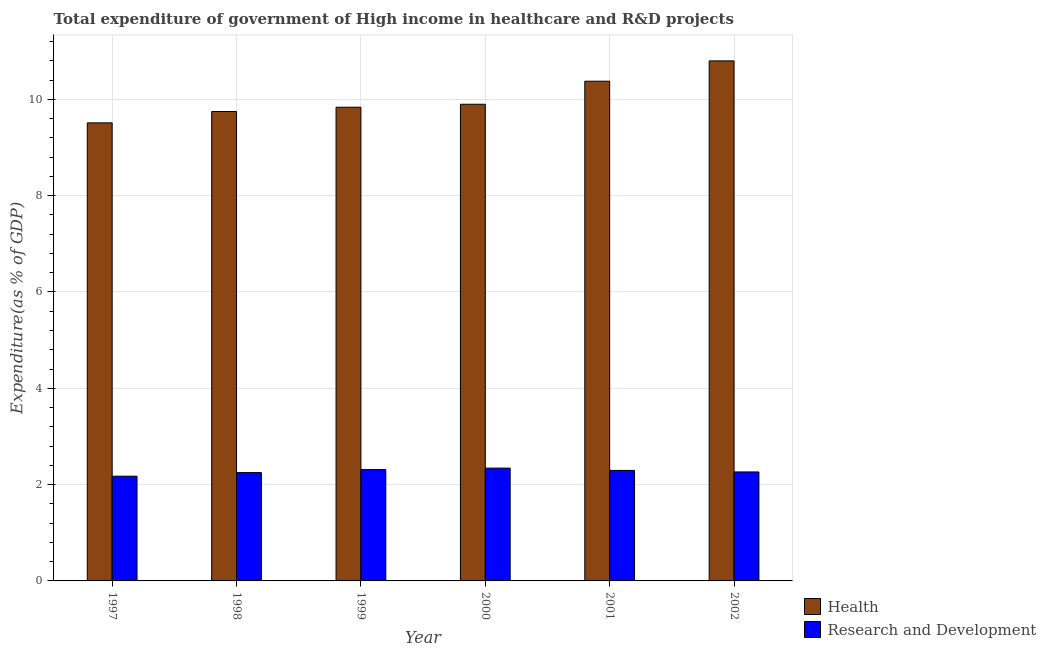How many groups of bars are there?
Keep it short and to the point. 6. Are the number of bars per tick equal to the number of legend labels?
Ensure brevity in your answer.  Yes. Are the number of bars on each tick of the X-axis equal?
Provide a short and direct response. Yes. How many bars are there on the 6th tick from the right?
Offer a very short reply. 2. What is the label of the 4th group of bars from the left?
Provide a succinct answer. 2000. What is the expenditure in r&d in 2001?
Provide a succinct answer. 2.29. Across all years, what is the maximum expenditure in healthcare?
Keep it short and to the point. 10.8. Across all years, what is the minimum expenditure in r&d?
Make the answer very short. 2.17. What is the total expenditure in healthcare in the graph?
Offer a terse response. 60.17. What is the difference between the expenditure in healthcare in 2001 and that in 2002?
Your response must be concise. -0.42. What is the difference between the expenditure in r&d in 1997 and the expenditure in healthcare in 1999?
Give a very brief answer. -0.14. What is the average expenditure in r&d per year?
Provide a short and direct response. 2.27. In the year 2001, what is the difference between the expenditure in r&d and expenditure in healthcare?
Give a very brief answer. 0. What is the ratio of the expenditure in r&d in 1998 to that in 2000?
Make the answer very short. 0.96. What is the difference between the highest and the second highest expenditure in healthcare?
Your answer should be compact. 0.42. What is the difference between the highest and the lowest expenditure in r&d?
Make the answer very short. 0.17. In how many years, is the expenditure in r&d greater than the average expenditure in r&d taken over all years?
Keep it short and to the point. 3. Is the sum of the expenditure in r&d in 1998 and 1999 greater than the maximum expenditure in healthcare across all years?
Your answer should be compact. Yes. What does the 1st bar from the left in 1999 represents?
Give a very brief answer. Health. What does the 2nd bar from the right in 2001 represents?
Offer a terse response. Health. How many bars are there?
Offer a terse response. 12. What is the difference between two consecutive major ticks on the Y-axis?
Keep it short and to the point. 2. Does the graph contain any zero values?
Your answer should be compact. No. Does the graph contain grids?
Provide a short and direct response. Yes. Where does the legend appear in the graph?
Your answer should be very brief. Bottom right. How many legend labels are there?
Your answer should be very brief. 2. How are the legend labels stacked?
Your answer should be compact. Vertical. What is the title of the graph?
Your response must be concise. Total expenditure of government of High income in healthcare and R&D projects. Does "Agricultural land" appear as one of the legend labels in the graph?
Your answer should be compact. No. What is the label or title of the Y-axis?
Make the answer very short. Expenditure(as % of GDP). What is the Expenditure(as % of GDP) in Health in 1997?
Offer a very short reply. 9.51. What is the Expenditure(as % of GDP) in Research and Development in 1997?
Make the answer very short. 2.17. What is the Expenditure(as % of GDP) in Health in 1998?
Provide a succinct answer. 9.75. What is the Expenditure(as % of GDP) in Research and Development in 1998?
Your answer should be very brief. 2.25. What is the Expenditure(as % of GDP) in Health in 1999?
Your response must be concise. 9.84. What is the Expenditure(as % of GDP) of Research and Development in 1999?
Give a very brief answer. 2.31. What is the Expenditure(as % of GDP) of Health in 2000?
Your answer should be compact. 9.9. What is the Expenditure(as % of GDP) in Research and Development in 2000?
Your response must be concise. 2.34. What is the Expenditure(as % of GDP) in Health in 2001?
Provide a succinct answer. 10.38. What is the Expenditure(as % of GDP) of Research and Development in 2001?
Give a very brief answer. 2.29. What is the Expenditure(as % of GDP) in Health in 2002?
Your answer should be very brief. 10.8. What is the Expenditure(as % of GDP) in Research and Development in 2002?
Provide a succinct answer. 2.26. Across all years, what is the maximum Expenditure(as % of GDP) of Health?
Your answer should be compact. 10.8. Across all years, what is the maximum Expenditure(as % of GDP) in Research and Development?
Your answer should be compact. 2.34. Across all years, what is the minimum Expenditure(as % of GDP) in Health?
Your answer should be very brief. 9.51. Across all years, what is the minimum Expenditure(as % of GDP) in Research and Development?
Ensure brevity in your answer.  2.17. What is the total Expenditure(as % of GDP) of Health in the graph?
Ensure brevity in your answer.  60.17. What is the total Expenditure(as % of GDP) of Research and Development in the graph?
Your answer should be very brief. 13.64. What is the difference between the Expenditure(as % of GDP) in Health in 1997 and that in 1998?
Make the answer very short. -0.24. What is the difference between the Expenditure(as % of GDP) of Research and Development in 1997 and that in 1998?
Make the answer very short. -0.08. What is the difference between the Expenditure(as % of GDP) of Health in 1997 and that in 1999?
Your answer should be very brief. -0.32. What is the difference between the Expenditure(as % of GDP) of Research and Development in 1997 and that in 1999?
Give a very brief answer. -0.14. What is the difference between the Expenditure(as % of GDP) in Health in 1997 and that in 2000?
Your answer should be compact. -0.39. What is the difference between the Expenditure(as % of GDP) of Research and Development in 1997 and that in 2000?
Offer a very short reply. -0.17. What is the difference between the Expenditure(as % of GDP) of Health in 1997 and that in 2001?
Your response must be concise. -0.86. What is the difference between the Expenditure(as % of GDP) in Research and Development in 1997 and that in 2001?
Keep it short and to the point. -0.12. What is the difference between the Expenditure(as % of GDP) in Health in 1997 and that in 2002?
Ensure brevity in your answer.  -1.29. What is the difference between the Expenditure(as % of GDP) in Research and Development in 1997 and that in 2002?
Provide a succinct answer. -0.09. What is the difference between the Expenditure(as % of GDP) of Health in 1998 and that in 1999?
Your answer should be very brief. -0.09. What is the difference between the Expenditure(as % of GDP) in Research and Development in 1998 and that in 1999?
Ensure brevity in your answer.  -0.06. What is the difference between the Expenditure(as % of GDP) of Health in 1998 and that in 2000?
Provide a succinct answer. -0.15. What is the difference between the Expenditure(as % of GDP) in Research and Development in 1998 and that in 2000?
Offer a terse response. -0.09. What is the difference between the Expenditure(as % of GDP) in Health in 1998 and that in 2001?
Provide a short and direct response. -0.63. What is the difference between the Expenditure(as % of GDP) of Research and Development in 1998 and that in 2001?
Offer a terse response. -0.04. What is the difference between the Expenditure(as % of GDP) of Health in 1998 and that in 2002?
Your answer should be compact. -1.05. What is the difference between the Expenditure(as % of GDP) in Research and Development in 1998 and that in 2002?
Offer a very short reply. -0.01. What is the difference between the Expenditure(as % of GDP) in Health in 1999 and that in 2000?
Keep it short and to the point. -0.06. What is the difference between the Expenditure(as % of GDP) of Research and Development in 1999 and that in 2000?
Ensure brevity in your answer.  -0.03. What is the difference between the Expenditure(as % of GDP) of Health in 1999 and that in 2001?
Offer a terse response. -0.54. What is the difference between the Expenditure(as % of GDP) of Research and Development in 1999 and that in 2001?
Keep it short and to the point. 0.02. What is the difference between the Expenditure(as % of GDP) in Health in 1999 and that in 2002?
Provide a succinct answer. -0.96. What is the difference between the Expenditure(as % of GDP) in Research and Development in 1999 and that in 2002?
Offer a very short reply. 0.05. What is the difference between the Expenditure(as % of GDP) of Health in 2000 and that in 2001?
Ensure brevity in your answer.  -0.48. What is the difference between the Expenditure(as % of GDP) in Research and Development in 2000 and that in 2001?
Offer a terse response. 0.05. What is the difference between the Expenditure(as % of GDP) in Health in 2000 and that in 2002?
Provide a short and direct response. -0.9. What is the difference between the Expenditure(as % of GDP) in Research and Development in 2000 and that in 2002?
Provide a short and direct response. 0.08. What is the difference between the Expenditure(as % of GDP) of Health in 2001 and that in 2002?
Your answer should be very brief. -0.42. What is the difference between the Expenditure(as % of GDP) of Research and Development in 2001 and that in 2002?
Keep it short and to the point. 0.03. What is the difference between the Expenditure(as % of GDP) in Health in 1997 and the Expenditure(as % of GDP) in Research and Development in 1998?
Offer a terse response. 7.26. What is the difference between the Expenditure(as % of GDP) of Health in 1997 and the Expenditure(as % of GDP) of Research and Development in 1999?
Ensure brevity in your answer.  7.2. What is the difference between the Expenditure(as % of GDP) in Health in 1997 and the Expenditure(as % of GDP) in Research and Development in 2000?
Provide a short and direct response. 7.17. What is the difference between the Expenditure(as % of GDP) in Health in 1997 and the Expenditure(as % of GDP) in Research and Development in 2001?
Make the answer very short. 7.22. What is the difference between the Expenditure(as % of GDP) of Health in 1997 and the Expenditure(as % of GDP) of Research and Development in 2002?
Your answer should be compact. 7.25. What is the difference between the Expenditure(as % of GDP) of Health in 1998 and the Expenditure(as % of GDP) of Research and Development in 1999?
Give a very brief answer. 7.44. What is the difference between the Expenditure(as % of GDP) of Health in 1998 and the Expenditure(as % of GDP) of Research and Development in 2000?
Offer a terse response. 7.41. What is the difference between the Expenditure(as % of GDP) of Health in 1998 and the Expenditure(as % of GDP) of Research and Development in 2001?
Your answer should be very brief. 7.45. What is the difference between the Expenditure(as % of GDP) of Health in 1998 and the Expenditure(as % of GDP) of Research and Development in 2002?
Provide a short and direct response. 7.48. What is the difference between the Expenditure(as % of GDP) of Health in 1999 and the Expenditure(as % of GDP) of Research and Development in 2000?
Offer a terse response. 7.49. What is the difference between the Expenditure(as % of GDP) of Health in 1999 and the Expenditure(as % of GDP) of Research and Development in 2001?
Your answer should be very brief. 7.54. What is the difference between the Expenditure(as % of GDP) of Health in 1999 and the Expenditure(as % of GDP) of Research and Development in 2002?
Give a very brief answer. 7.57. What is the difference between the Expenditure(as % of GDP) in Health in 2000 and the Expenditure(as % of GDP) in Research and Development in 2001?
Offer a very short reply. 7.6. What is the difference between the Expenditure(as % of GDP) in Health in 2000 and the Expenditure(as % of GDP) in Research and Development in 2002?
Your answer should be compact. 7.63. What is the difference between the Expenditure(as % of GDP) in Health in 2001 and the Expenditure(as % of GDP) in Research and Development in 2002?
Your answer should be very brief. 8.11. What is the average Expenditure(as % of GDP) of Health per year?
Provide a short and direct response. 10.03. What is the average Expenditure(as % of GDP) of Research and Development per year?
Offer a terse response. 2.27. In the year 1997, what is the difference between the Expenditure(as % of GDP) of Health and Expenditure(as % of GDP) of Research and Development?
Keep it short and to the point. 7.34. In the year 1998, what is the difference between the Expenditure(as % of GDP) in Health and Expenditure(as % of GDP) in Research and Development?
Make the answer very short. 7.5. In the year 1999, what is the difference between the Expenditure(as % of GDP) of Health and Expenditure(as % of GDP) of Research and Development?
Your response must be concise. 7.52. In the year 2000, what is the difference between the Expenditure(as % of GDP) of Health and Expenditure(as % of GDP) of Research and Development?
Provide a succinct answer. 7.56. In the year 2001, what is the difference between the Expenditure(as % of GDP) in Health and Expenditure(as % of GDP) in Research and Development?
Keep it short and to the point. 8.08. In the year 2002, what is the difference between the Expenditure(as % of GDP) of Health and Expenditure(as % of GDP) of Research and Development?
Give a very brief answer. 8.54. What is the ratio of the Expenditure(as % of GDP) in Health in 1997 to that in 1998?
Provide a succinct answer. 0.98. What is the ratio of the Expenditure(as % of GDP) of Research and Development in 1997 to that in 1998?
Ensure brevity in your answer.  0.97. What is the ratio of the Expenditure(as % of GDP) of Research and Development in 1997 to that in 1999?
Offer a terse response. 0.94. What is the ratio of the Expenditure(as % of GDP) of Research and Development in 1997 to that in 2000?
Make the answer very short. 0.93. What is the ratio of the Expenditure(as % of GDP) of Research and Development in 1997 to that in 2001?
Your answer should be very brief. 0.95. What is the ratio of the Expenditure(as % of GDP) in Health in 1997 to that in 2002?
Keep it short and to the point. 0.88. What is the ratio of the Expenditure(as % of GDP) in Research and Development in 1997 to that in 2002?
Give a very brief answer. 0.96. What is the ratio of the Expenditure(as % of GDP) in Health in 1998 to that in 2000?
Give a very brief answer. 0.98. What is the ratio of the Expenditure(as % of GDP) of Research and Development in 1998 to that in 2000?
Provide a short and direct response. 0.96. What is the ratio of the Expenditure(as % of GDP) of Health in 1998 to that in 2001?
Keep it short and to the point. 0.94. What is the ratio of the Expenditure(as % of GDP) in Research and Development in 1998 to that in 2001?
Offer a very short reply. 0.98. What is the ratio of the Expenditure(as % of GDP) in Health in 1998 to that in 2002?
Keep it short and to the point. 0.9. What is the ratio of the Expenditure(as % of GDP) in Research and Development in 1998 to that in 2002?
Ensure brevity in your answer.  0.99. What is the ratio of the Expenditure(as % of GDP) of Research and Development in 1999 to that in 2000?
Your response must be concise. 0.99. What is the ratio of the Expenditure(as % of GDP) of Health in 1999 to that in 2001?
Your response must be concise. 0.95. What is the ratio of the Expenditure(as % of GDP) of Research and Development in 1999 to that in 2001?
Offer a terse response. 1.01. What is the ratio of the Expenditure(as % of GDP) in Health in 1999 to that in 2002?
Your response must be concise. 0.91. What is the ratio of the Expenditure(as % of GDP) of Research and Development in 1999 to that in 2002?
Make the answer very short. 1.02. What is the ratio of the Expenditure(as % of GDP) in Health in 2000 to that in 2001?
Make the answer very short. 0.95. What is the ratio of the Expenditure(as % of GDP) in Research and Development in 2000 to that in 2001?
Your answer should be very brief. 1.02. What is the ratio of the Expenditure(as % of GDP) in Health in 2000 to that in 2002?
Ensure brevity in your answer.  0.92. What is the ratio of the Expenditure(as % of GDP) in Research and Development in 2000 to that in 2002?
Offer a terse response. 1.04. What is the ratio of the Expenditure(as % of GDP) of Health in 2001 to that in 2002?
Provide a succinct answer. 0.96. What is the ratio of the Expenditure(as % of GDP) of Research and Development in 2001 to that in 2002?
Give a very brief answer. 1.01. What is the difference between the highest and the second highest Expenditure(as % of GDP) in Health?
Offer a terse response. 0.42. What is the difference between the highest and the second highest Expenditure(as % of GDP) of Research and Development?
Give a very brief answer. 0.03. What is the difference between the highest and the lowest Expenditure(as % of GDP) of Health?
Offer a very short reply. 1.29. What is the difference between the highest and the lowest Expenditure(as % of GDP) of Research and Development?
Your response must be concise. 0.17. 